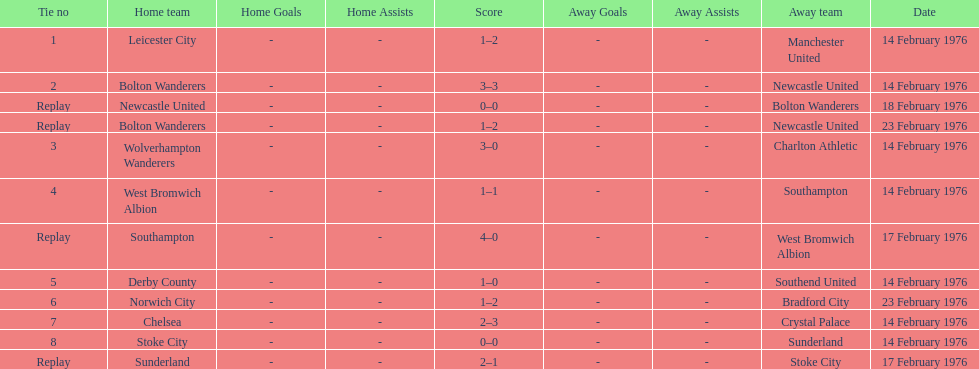Parse the full table. {'header': ['Tie no', 'Home team', 'Home Goals', 'Home Assists', 'Score', 'Away Goals', 'Away Assists', 'Away team', 'Date'], 'rows': [['1', 'Leicester City', '-', '-', '1–2', '-', '-', 'Manchester United', '14 February 1976'], ['2', 'Bolton Wanderers', '-', '-', '3–3', '-', '-', 'Newcastle United', '14 February 1976'], ['Replay', 'Newcastle United', '-', '-', '0–0', '-', '-', 'Bolton Wanderers', '18 February 1976'], ['Replay', 'Bolton Wanderers', '-', '-', '1–2', '-', '-', 'Newcastle United', '23 February 1976'], ['3', 'Wolverhampton Wanderers', '-', '-', '3–0', '-', '-', 'Charlton Athletic', '14 February 1976'], ['4', 'West Bromwich Albion', '-', '-', '1–1', '-', '-', 'Southampton', '14 February 1976'], ['Replay', 'Southampton', '-', '-', '4–0', '-', '-', 'West Bromwich Albion', '17 February 1976'], ['5', 'Derby County', '-', '-', '1–0', '-', '-', 'Southend United', '14 February 1976'], ['6', 'Norwich City', '-', '-', '1–2', '-', '-', 'Bradford City', '23 February 1976'], ['7', 'Chelsea', '-', '-', '2–3', '-', '-', 'Crystal Palace', '14 February 1976'], ['8', 'Stoke City', '-', '-', '0–0', '-', '-', 'Sunderland', '14 February 1976'], ['Replay', 'Sunderland', '-', '-', '2–1', '-', '-', 'Stoke City', '17 February 1976']]} How many games played by sunderland are listed here? 2. 